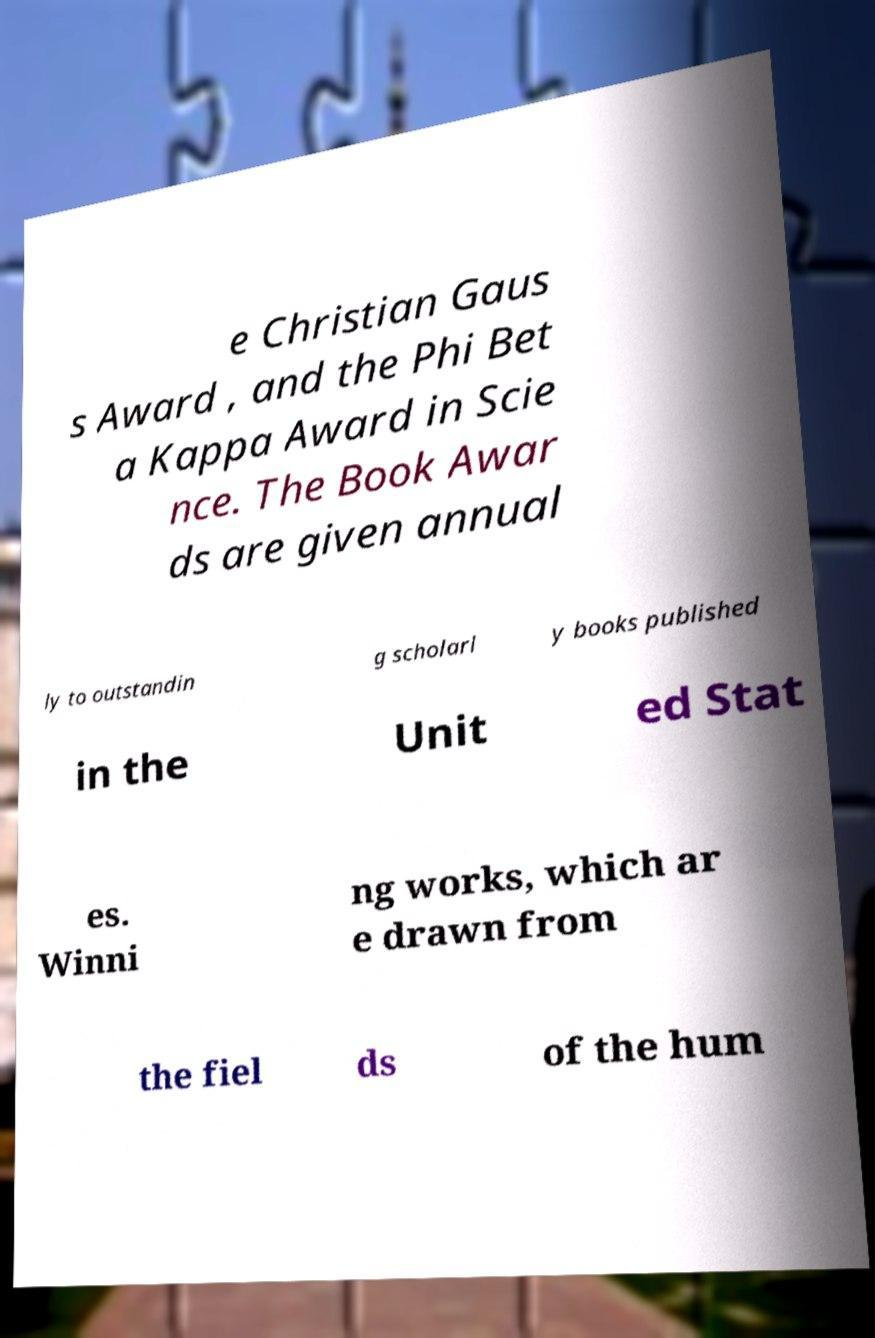There's text embedded in this image that I need extracted. Can you transcribe it verbatim? e Christian Gaus s Award , and the Phi Bet a Kappa Award in Scie nce. The Book Awar ds are given annual ly to outstandin g scholarl y books published in the Unit ed Stat es. Winni ng works, which ar e drawn from the fiel ds of the hum 